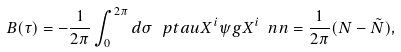Convert formula to latex. <formula><loc_0><loc_0><loc_500><loc_500>B ( \tau ) = - \frac { 1 } { 2 \pi } \int _ { 0 } ^ { 2 \pi } d \sigma \, \ p t a u X ^ { i } \psi g X ^ { i } \ n n = \frac { 1 } { 2 \pi } ( N - \tilde { N } ) ,</formula> 